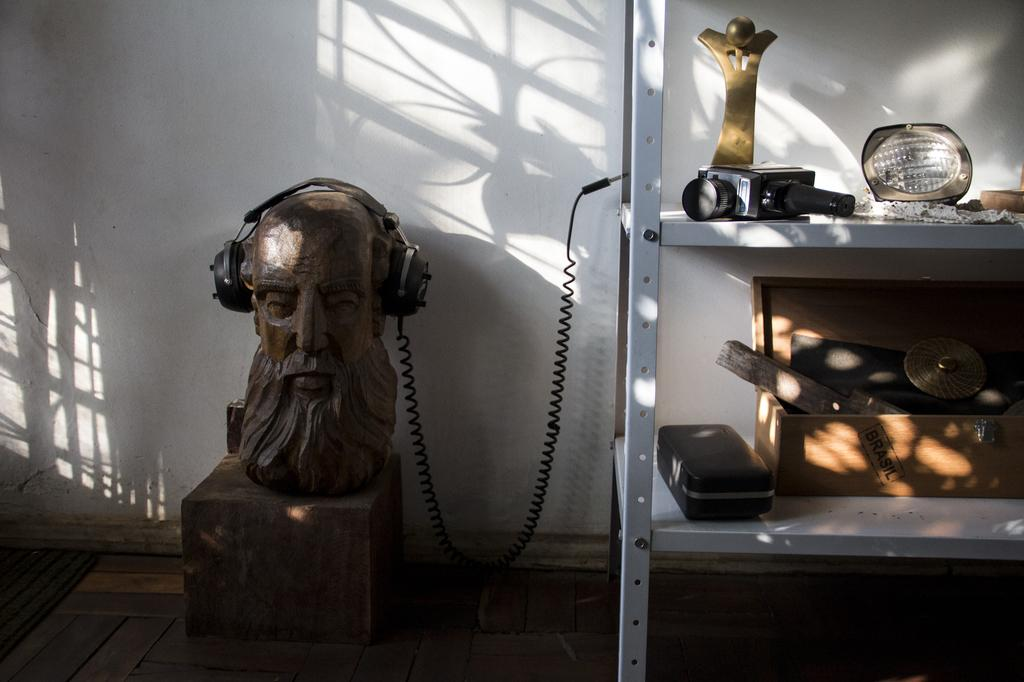What is the main subject of the image? There is a statue in the image. What is on the statue? Headphones are on the statue. What can be seen on the right side of the image? There is a camera, a wooden box, and objects placed on racks on the right side of the image. What is visible in the background of the image? There is a wall visible on the backside of the image. What type of ball is being used by the pig in the image? There is no ball or pig present in the image; it features a statue with headphones and various objects on the right side. 